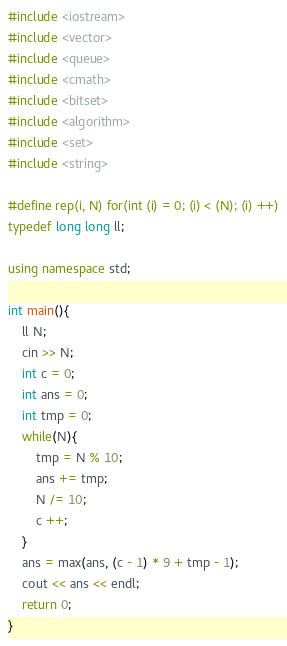Convert code to text. <code><loc_0><loc_0><loc_500><loc_500><_C++_>#include <iostream>
#include <vector>
#include <queue>
#include <cmath>
#include <bitset>
#include <algorithm>
#include <set>
#include <string>

#define rep(i, N) for(int (i) = 0; (i) < (N); (i) ++)
typedef long long ll;

using namespace std;

int main(){
    ll N;
    cin >> N;
    int c = 0;
    int ans = 0;
    int tmp = 0;
    while(N){
        tmp = N % 10;
        ans += tmp;
        N /= 10;
        c ++;
    }
    ans = max(ans, (c - 1) * 9 + tmp - 1);
    cout << ans << endl;
    return 0;
}
</code> 